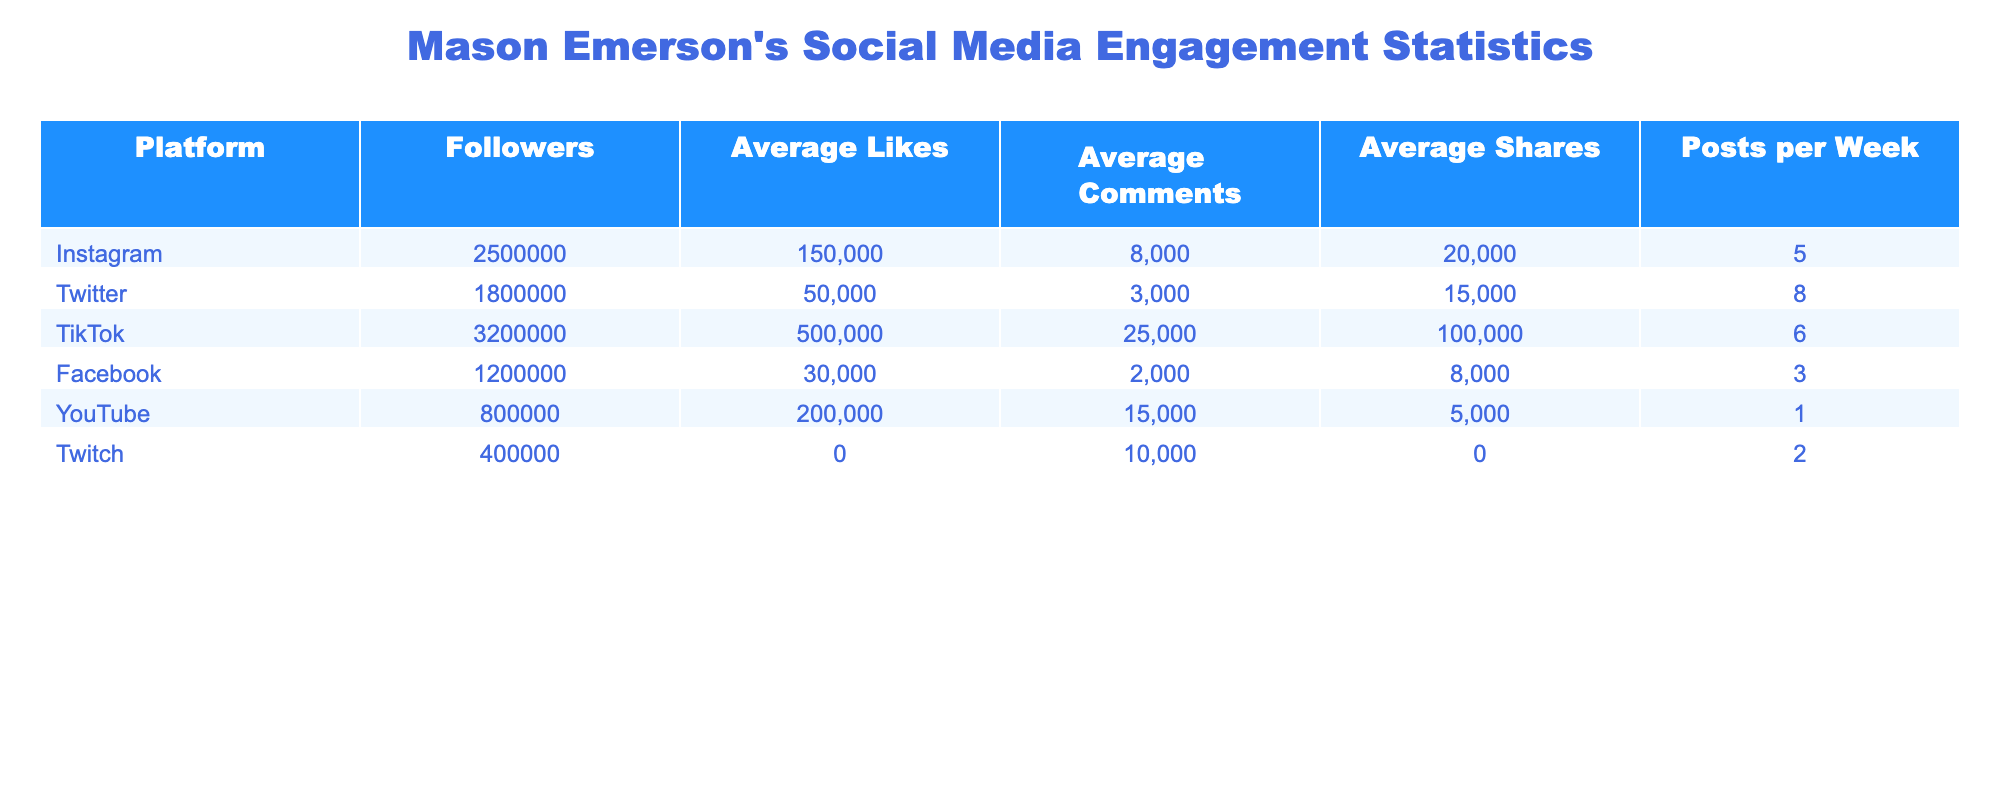What is the total number of followers across all platforms for Mason Emerson? To find the total followers, we sum the followers from all listed platforms: 2,500,000 (Instagram) + 1,800,000 (Twitter) + 3,200,000 (TikTok) + 1,200,000 (Facebook) + 800,000 (YouTube) + 400,000 (Twitch) = 9,900,000.
Answer: 9,900,000 Which platform has the highest average likes? By examining the table, TikTok has the highest average likes with 500,000, compared to other platforms.
Answer: TikTok How many average comments does YouTube receive? The table indicates that YouTube receives an average of 15,000 comments.
Answer: 15,000 Is there any platform where the average shares are reported as N/A? Yes, Twitch shows N/A for average shares in the table, indicating that this information is not available.
Answer: Yes What is the average number of posts per week across all platforms? To find the average posts per week, we sum the posts per week (5 + 8 + 6 + 3 + 1 + 2) = 25, then divide by the number of platforms (6): 25/6 ≈ 4.17.
Answer: Approximately 4.17 Which platform has the lowest number of average comments? Looking at the table, Facebook has the lowest average comments with only 2,000.
Answer: Facebook What is the difference in average likes between TikTok and Instagram? The difference is calculated by subtracting Instagram's average likes (150,000) from TikTok's average likes (500,000): 500,000 - 150,000 = 350,000.
Answer: 350,000 If we consider only platforms with available average shares, what is the average number of shares for these platforms? Only Instagram, Twitter, and YouTube have available average shares: (20,000 + 15,000 + 5,000) = 40,000, and the total number of platforms is 3. The average is 40,000/3 = approximately 13,333.
Answer: Approximately 13,333 What percentage of followers does TikTok have compared to the total number of followers? TikTok has 3,200,000 followers. To find the percentage, we use the formula: (3,200,000/9,900,000) * 100 ≈ 32.32%.
Answer: Approximately 32.32% Is the total number of average likes for all platforms greater than 1,000,000? The sum of average likes is 150,000 (Instagram) + 50,000 (Twitter) + 500,000 (TikTok) + 30,000 (Facebook) + 200,000 (YouTube) + 0 (Twitch) = 930,000, which is less than 1,000,000.
Answer: No 